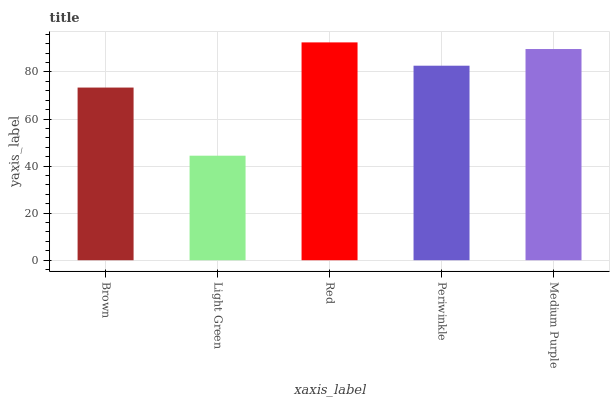Is Light Green the minimum?
Answer yes or no. Yes. Is Red the maximum?
Answer yes or no. Yes. Is Red the minimum?
Answer yes or no. No. Is Light Green the maximum?
Answer yes or no. No. Is Red greater than Light Green?
Answer yes or no. Yes. Is Light Green less than Red?
Answer yes or no. Yes. Is Light Green greater than Red?
Answer yes or no. No. Is Red less than Light Green?
Answer yes or no. No. Is Periwinkle the high median?
Answer yes or no. Yes. Is Periwinkle the low median?
Answer yes or no. Yes. Is Brown the high median?
Answer yes or no. No. Is Brown the low median?
Answer yes or no. No. 